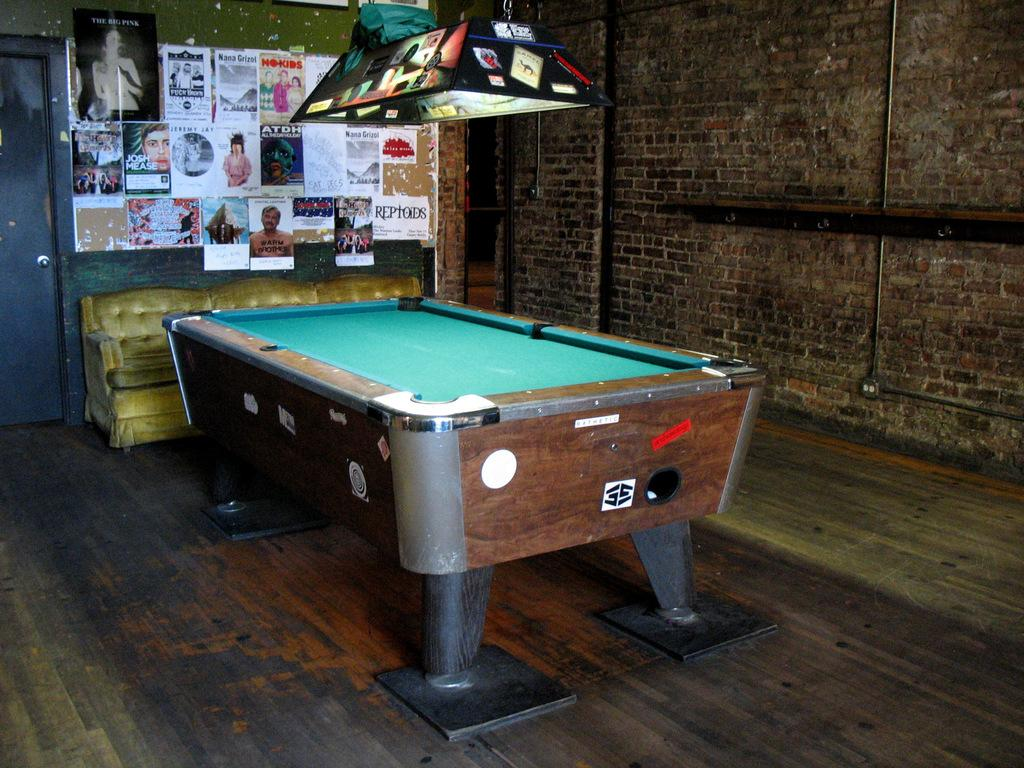What game is being played in the image? There is a snooker in the image. What type of furniture is present in the image? There is a table in the image. What decorations can be seen on the wall? There are stickers and posters on the wall. What architectural feature is visible in the image? There is a door in the image. Can you tell me how many times the snooker has been bitten in the image? There is no indication that the snooker has been bitten in the image. What type of thread is used to hang the posters on the wall? The image does not provide information about the type of thread used to hang the posters on the wall. 